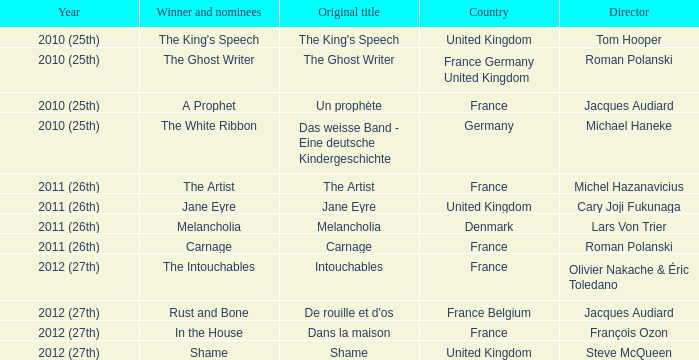What was the original name of the king's speech? The King's Speech. 